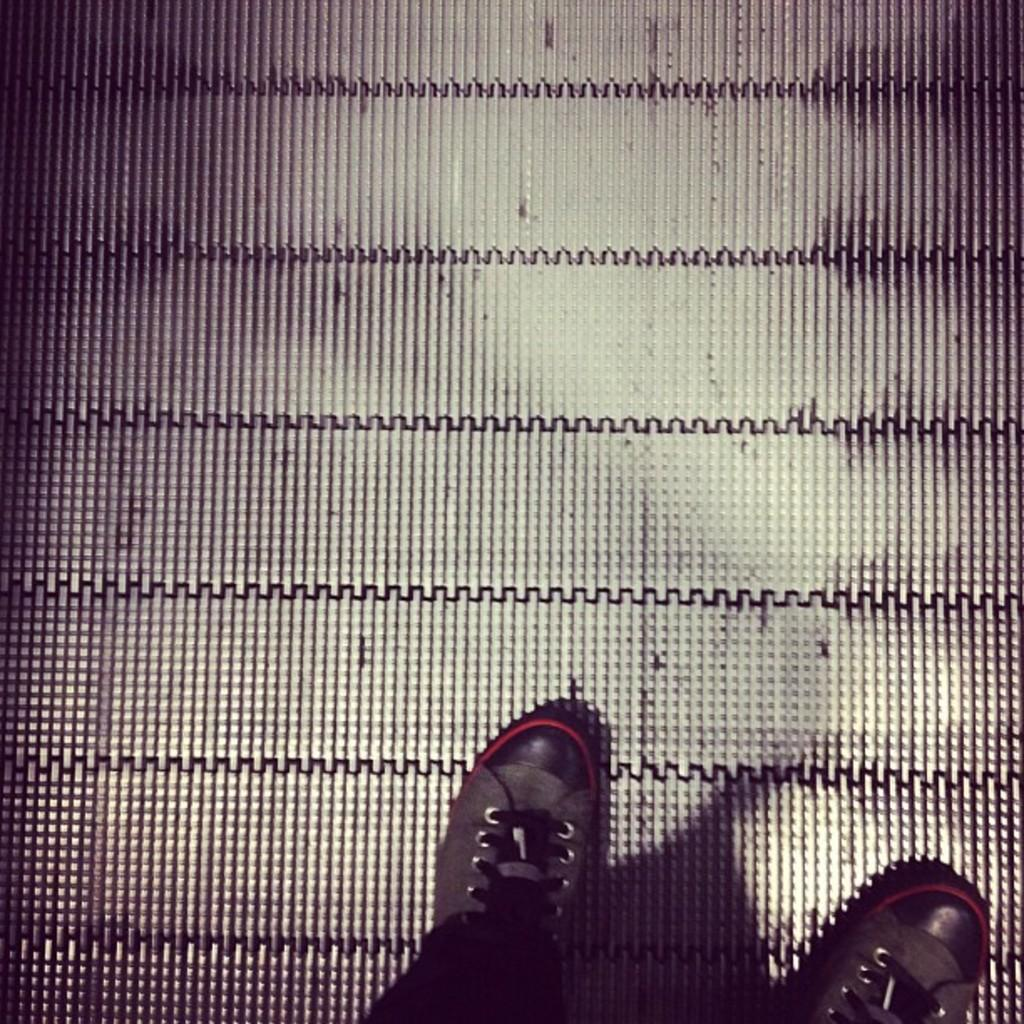What part of a person's body can be seen in the image? There is a person's leg visible in the image. What type of footwear is the person wearing? The person is wearing shoes. What surface is the person standing on? The person is standing on the floor. What type of juice is being squeezed from the corn in the image? There is no juice or corn present in the image; it only shows a person's leg wearing shoes and standing on the floor. 